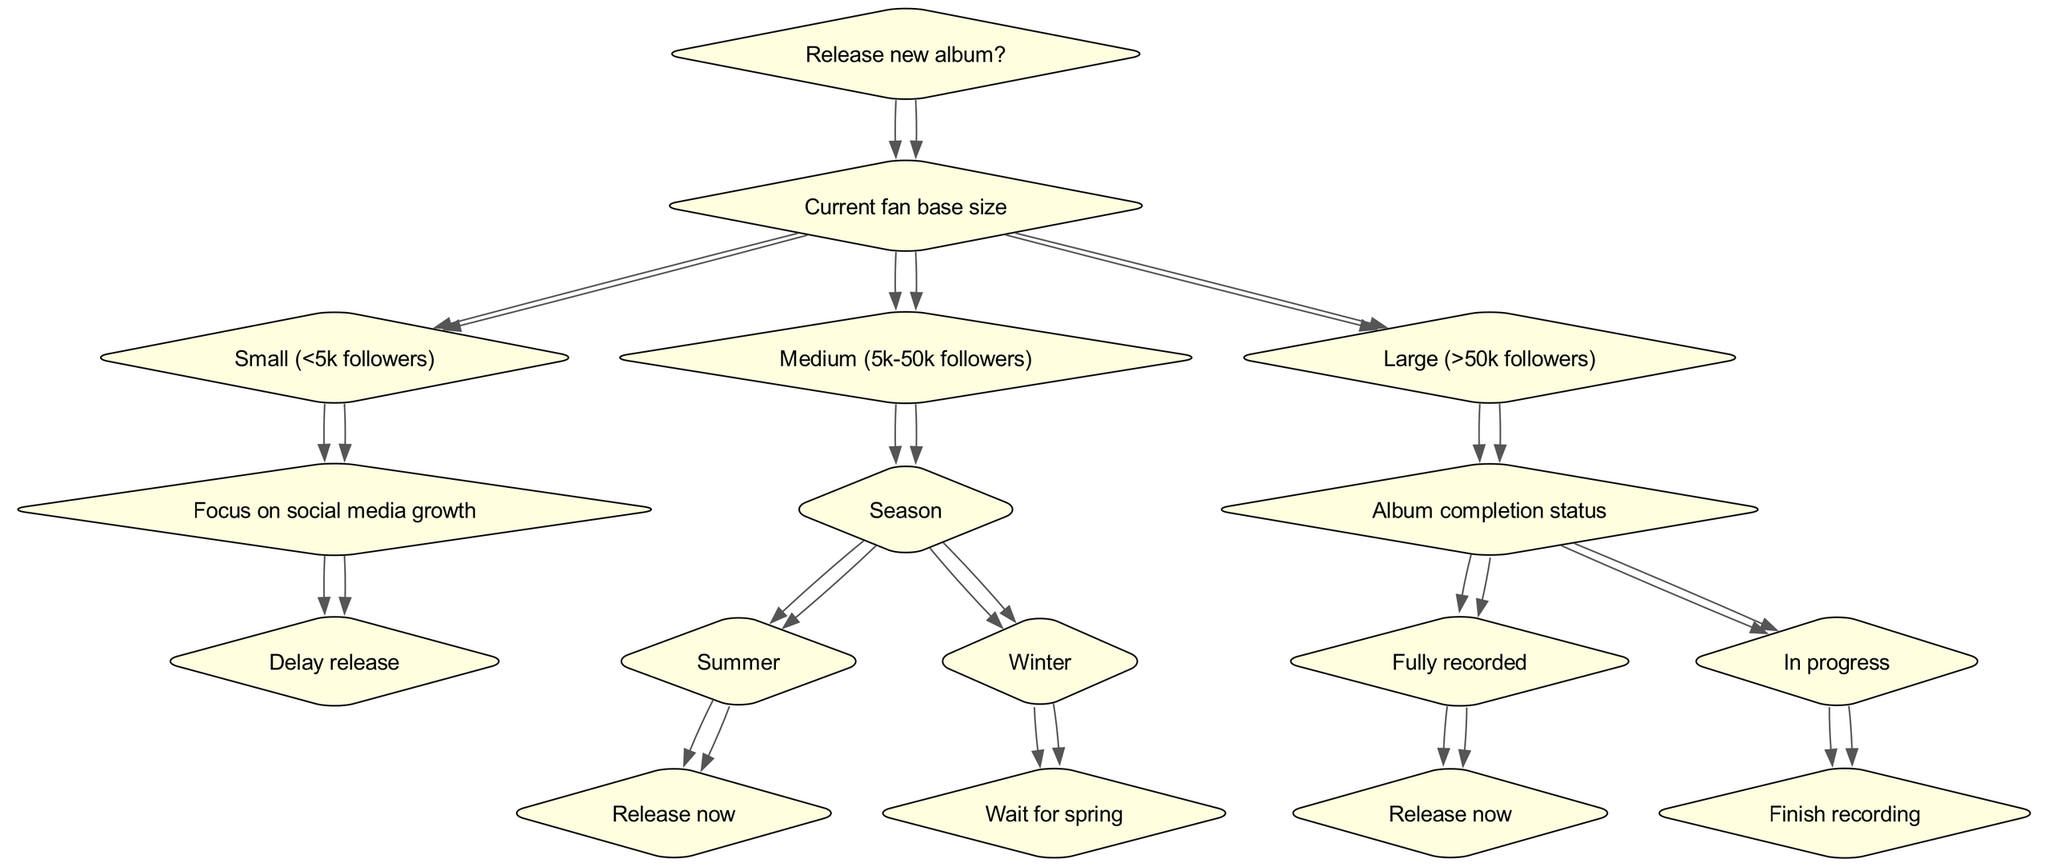What is the root question of the diagram? The root of the diagram is clearly stated at the top as "Release new album?". This serves as the central question from which all subsequent decisions stem.
Answer: Release new album? How many root children does the decision tree have? The diagram shows three primary branches stemming from the root, corresponding to different fan base sizes: Small, Medium, and Large. Thus, the number of children is three.
Answer: 3 What is the strategy for a small fan base? If the fan base is small (less than 5k followers), the strategy focuses on social media growth and suggests delaying the release until this growth is achieved.
Answer: Delay release What season should an artist with a medium fan base wait for if they want to release in winter? For artists with a medium fan base (5k-50k followers) who find themselves in winter, the diagram advises them to wait for spring before releasing their album.
Answer: Wait for spring What do you do if you have a large fan base and your album is still in progress? According to the diagram, if the artist has a large fan base (greater than 50k followers) and the album is in progress, the next step is to finish recording the album before considering a release.
Answer: Finish recording What is required to release an album immediately for a large fan base? As per the diagram, to release an album immediate for a large fan base, the album must be fully recorded. Therefore, full recordings are essential for an immediate release.
Answer: Release now What happens if the fan base is medium and it’s summer? When the fan base is medium (5k-50k followers) and it is summer, the diagram indicates that the artist should release the album now. All conditions are met for an immediate release in this scenario.
Answer: Release now What is the connection between fan base size and decision-making? The decision-making process in the diagram is heavily influenced by the fan base size, as it determines the subsequent strategies and timing for the album release. The larger the fan base, the more immediate the release options become.
Answer: Fan base size influences strategies What action should an artist take if they have a fully recorded album and a large fan base? If an artist has completed the recording of their album and has a large fan base, the diagram suggests that they can proceed to release the album immediately.
Answer: Release now 